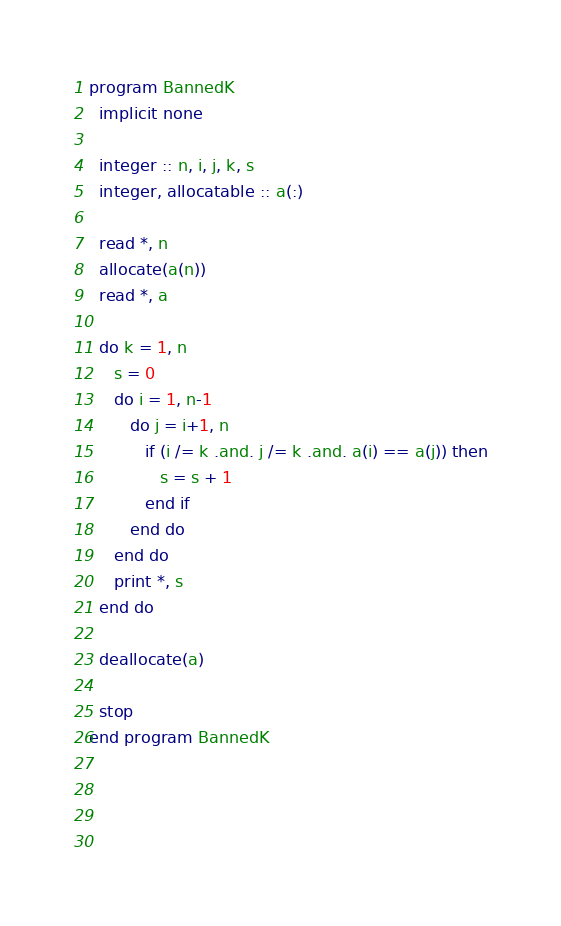<code> <loc_0><loc_0><loc_500><loc_500><_FORTRAN_>program BannedK
  implicit none

  integer :: n, i, j, k, s
  integer, allocatable :: a(:)

  read *, n
  allocate(a(n))
  read *, a

  do k = 1, n
     s = 0
     do i = 1, n-1
        do j = i+1, n
           if (i /= k .and. j /= k .and. a(i) == a(j)) then
              s = s + 1
           end if
        end do
     end do
     print *, s
  end do

  deallocate(a)

  stop
end program BannedK



  

</code> 